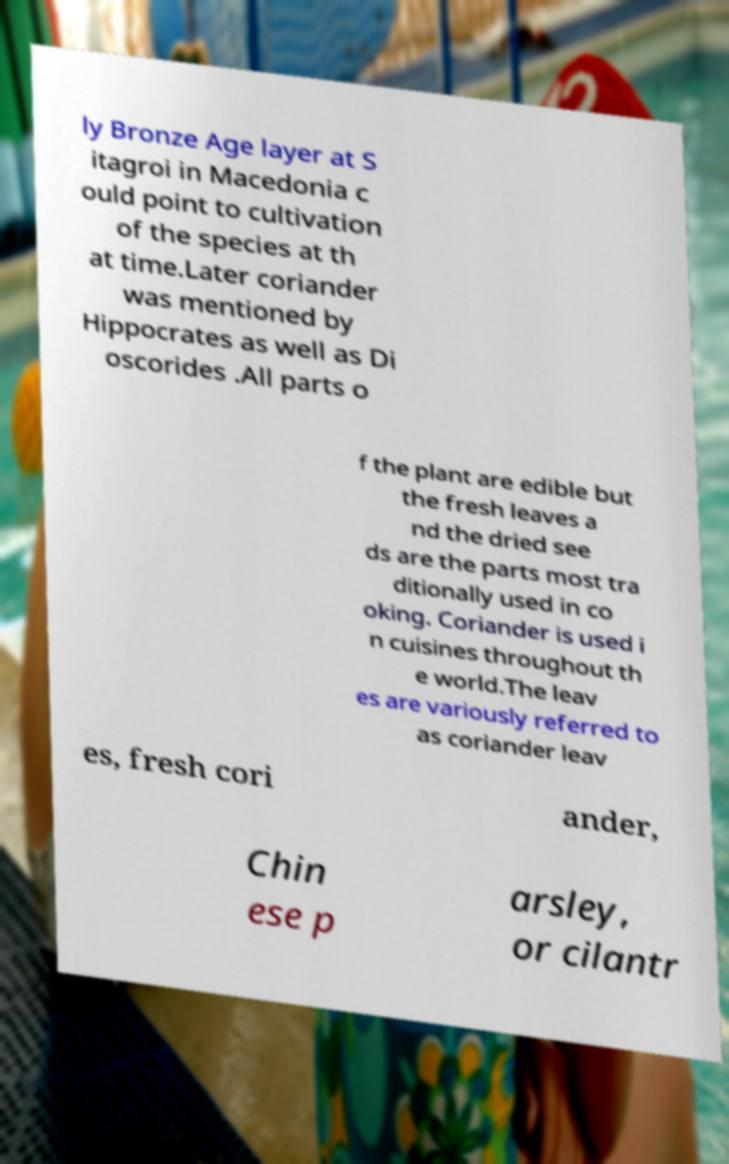Could you assist in decoding the text presented in this image and type it out clearly? ly Bronze Age layer at S itagroi in Macedonia c ould point to cultivation of the species at th at time.Later coriander was mentioned by Hippocrates as well as Di oscorides .All parts o f the plant are edible but the fresh leaves a nd the dried see ds are the parts most tra ditionally used in co oking. Coriander is used i n cuisines throughout th e world.The leav es are variously referred to as coriander leav es, fresh cori ander, Chin ese p arsley, or cilantr 